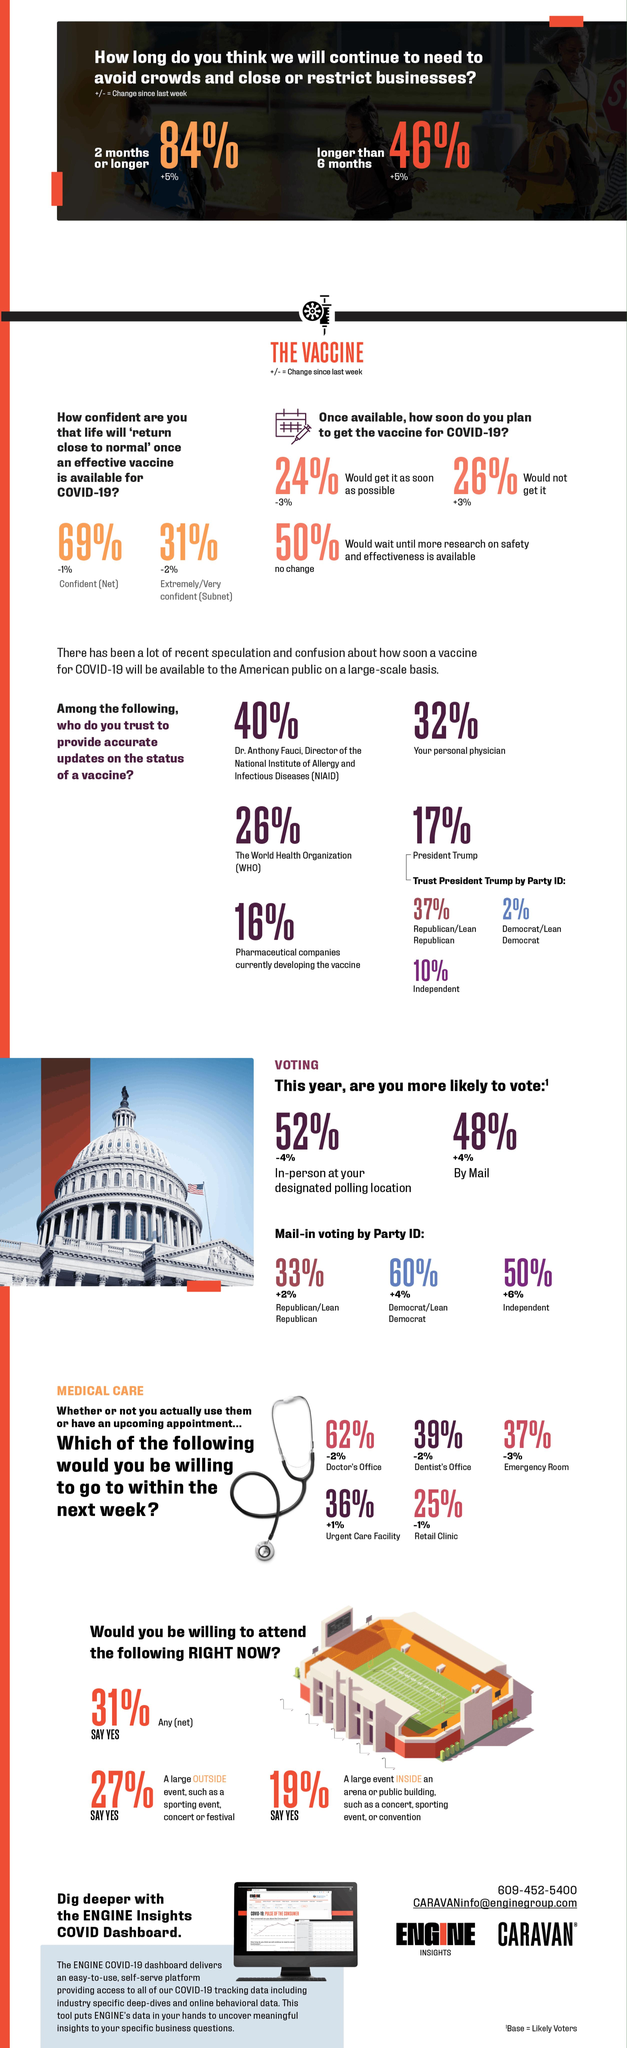Draw attention to some important aspects in this diagram. A significant percentage of people, approximately 48%, are likely to vote by mail. The majority of individuals trust Dr. Anthony Fauci regarding updates on COVID-19 vaccine status. According to the survey, 69% of people are confident that their lives will return to normal when a vaccine becomes available. According to the survey, 50% of the respondents indicated that they would wait for research about vaccine effectiveness before receiving it. A recent survey revealed that 19% of individuals expressed a willingness to attend a large indoor event such as a concert. 